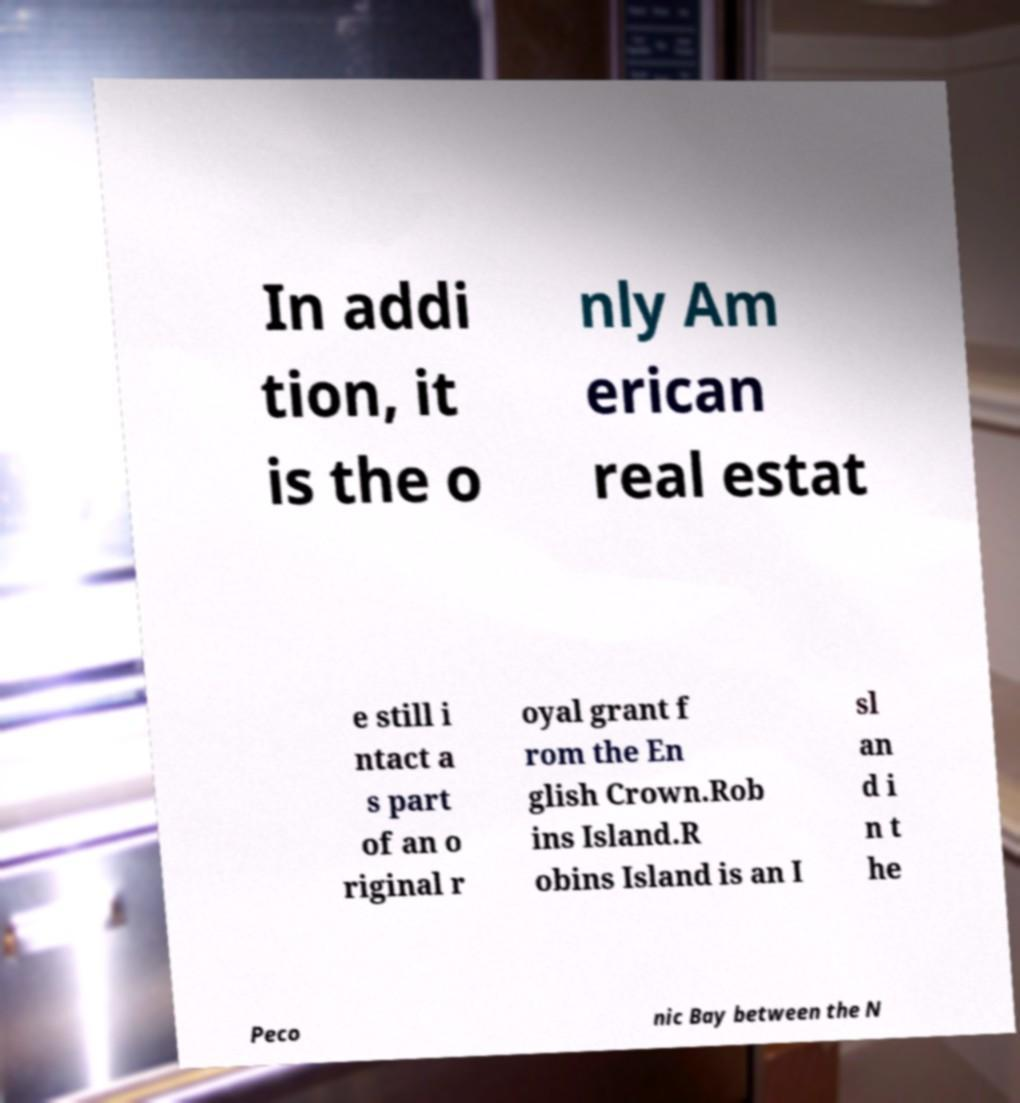There's text embedded in this image that I need extracted. Can you transcribe it verbatim? In addi tion, it is the o nly Am erican real estat e still i ntact a s part of an o riginal r oyal grant f rom the En glish Crown.Rob ins Island.R obins Island is an I sl an d i n t he Peco nic Bay between the N 